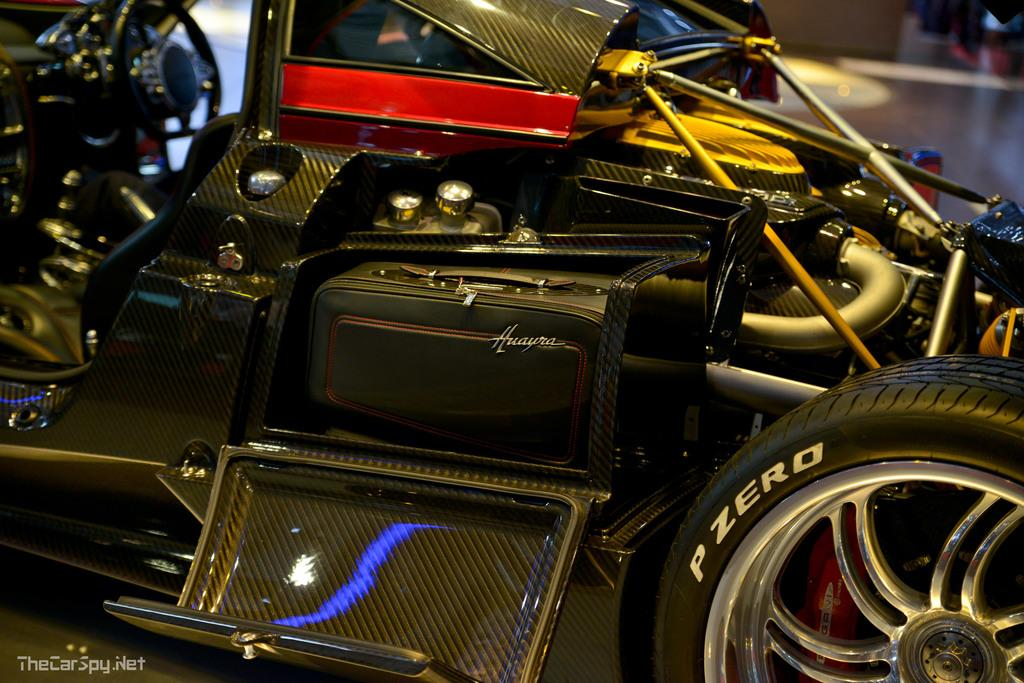What object can be seen in the right side corner of the image? There is a tyre in the right side corner of the image. What is the main subject in the middle of the image? There are vehicles and metal instruments in the middle of the image. Can you see a field in the image? There is no field present in the image. Is there a hat visible in the image? There is no hat present in the image. 